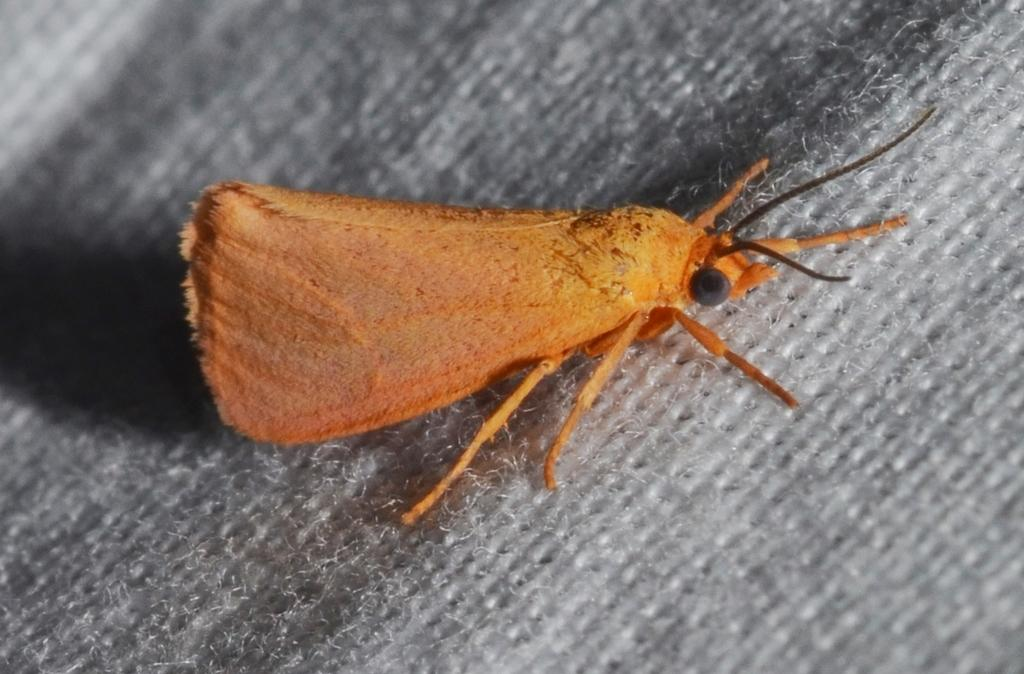What type of creature is present in the image? There is an insect in the image. Where is the insect located in the image? The insect is on a platform. What type of learning is the insect participating in on the platform? There is no indication in the image that the insect is participating in any learning activities. 